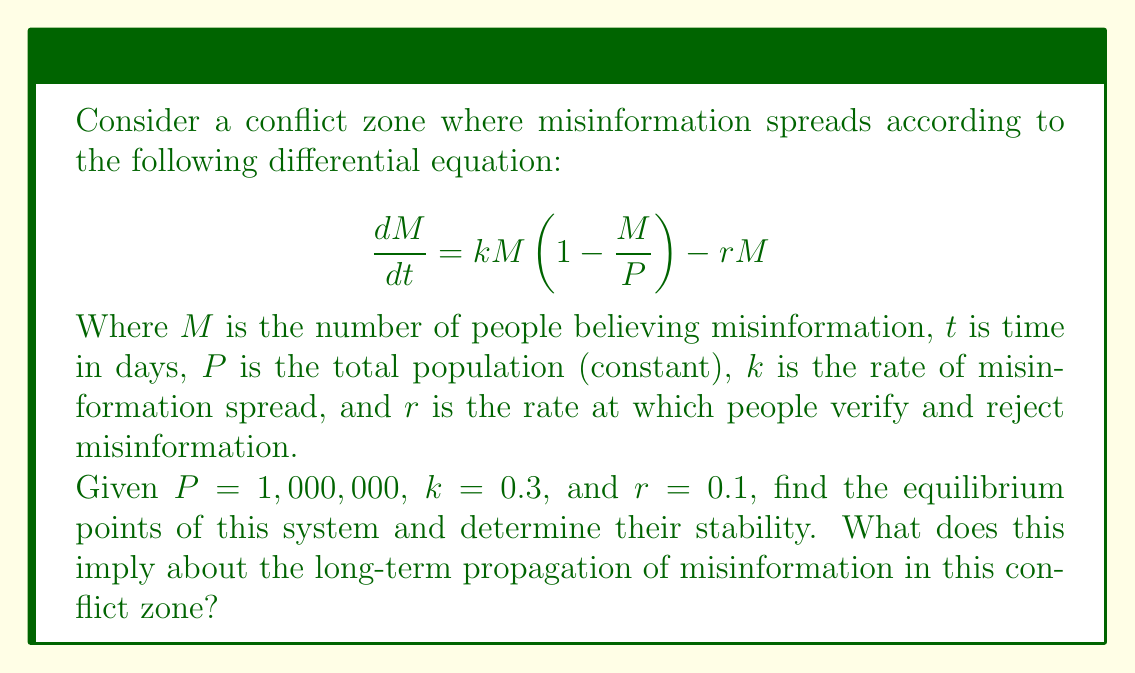Could you help me with this problem? To solve this problem, we'll follow these steps:

1) Find the equilibrium points by setting $\frac{dM}{dt} = 0$:

   $$0 = kM(1-\frac{M}{P}) - rM$$
   $$0 = 0.3M(1-\frac{M}{1,000,000}) - 0.1M$$

2) Factor out M:

   $$0 = M(0.3-\frac{0.3M}{1,000,000} - 0.1)$$
   $$0 = M(0.2-\frac{0.3M}{1,000,000})$$

3) Solve for M:

   Either $M = 0$ or $0.2-\frac{0.3M}{1,000,000} = 0$
   
   From the second equation:
   $$0.2 = \frac{0.3M}{1,000,000}$$
   $$M = \frac{0.2 * 1,000,000}{0.3} = 666,667$$

4) The equilibrium points are thus $M = 0$ and $M = 666,667$.

5) To determine stability, we evaluate the derivative of $\frac{dM}{dt}$ with respect to $M$ at each equilibrium point:

   $$\frac{d}{dM}(\frac{dM}{dt}) = k(1-\frac{2M}{P}) - r$$

6) At $M = 0$:
   
   $$\frac{d}{dM}(\frac{dM}{dt}) = 0.3(1-\frac{2(0)}{1,000,000}) - 0.1 = 0.2$$

   This is positive, so $M = 0$ is an unstable equilibrium.

7) At $M = 666,667$:

   $$\frac{d}{dM}(\frac{dM}{dt}) = 0.3(1-\frac{2(666,667)}{1,000,000}) - 0.1 = -0.2$$

   This is negative, so $M = 666,667$ is a stable equilibrium.

This implies that in the long term, misinformation will spread to about 66.7% of the population in this conflict zone, regardless of the initial number of people believing the misinformation (unless that initial number is exactly 0).
Answer: Equilibrium points: $M = 0$ (unstable) and $M = 666,667$ (stable). Long-term, misinformation affects 66.7% of population. 